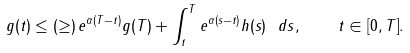Convert formula to latex. <formula><loc_0><loc_0><loc_500><loc_500>g ( t ) \leq ( \geq ) \, e ^ { \alpha ( T - t ) } g ( T ) + \int _ { t } ^ { T } e ^ { \alpha ( s - t ) } h ( s ) \ d s , \quad t \in [ 0 , T ] .</formula> 